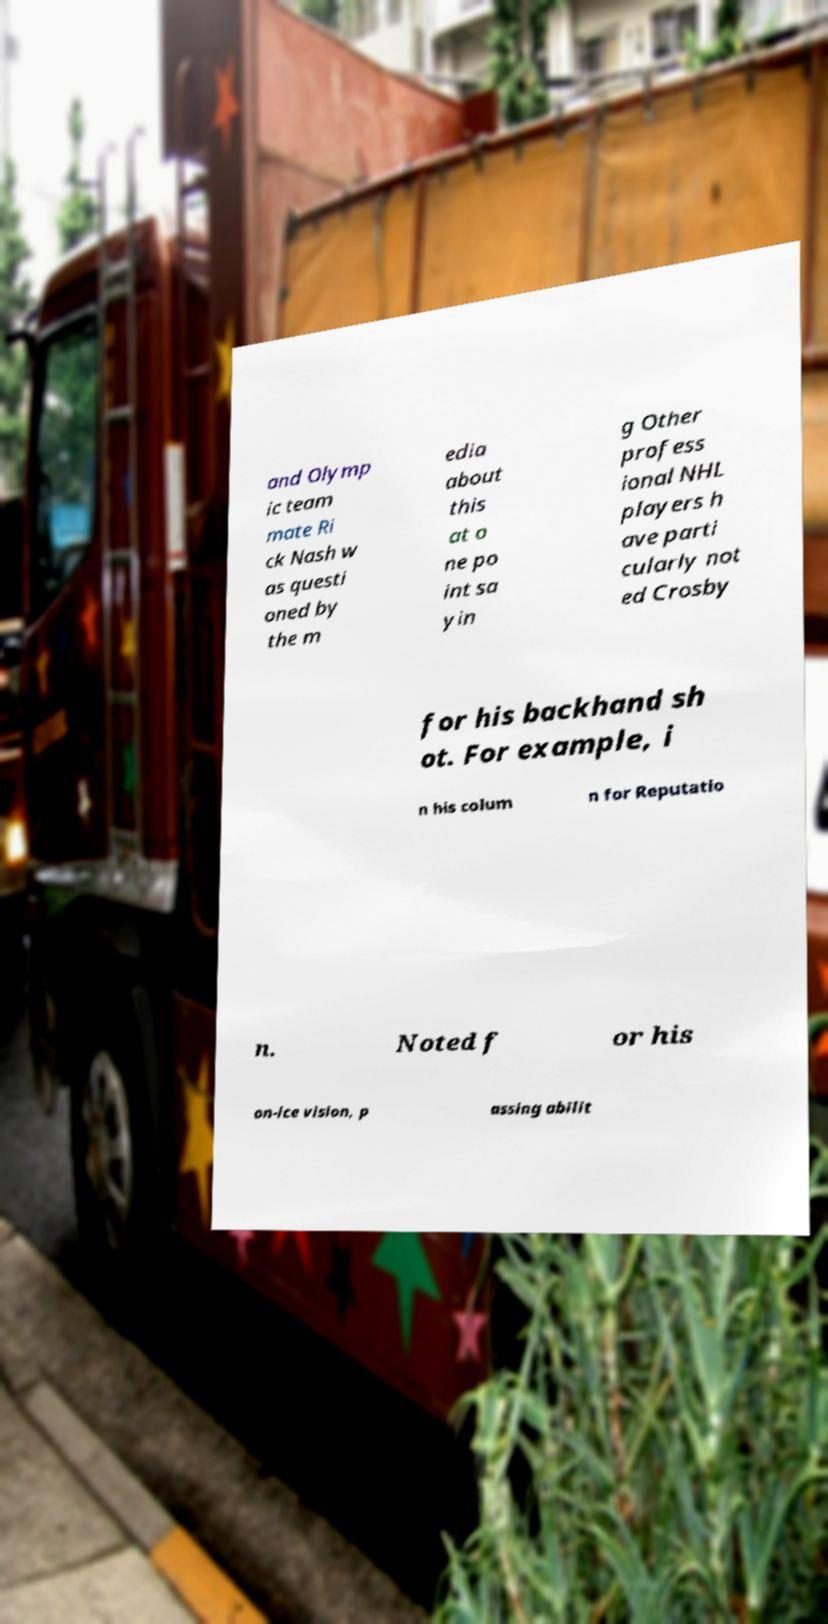Can you accurately transcribe the text from the provided image for me? and Olymp ic team mate Ri ck Nash w as questi oned by the m edia about this at o ne po int sa yin g Other profess ional NHL players h ave parti cularly not ed Crosby for his backhand sh ot. For example, i n his colum n for Reputatio n. Noted f or his on-ice vision, p assing abilit 